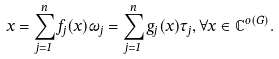<formula> <loc_0><loc_0><loc_500><loc_500>x = \sum _ { j = 1 } ^ { n } f _ { j } ( x ) \omega _ { j } = \sum _ { j = 1 } ^ { n } g _ { j } ( x ) \tau _ { j } , \forall x \in \mathbb { C } ^ { o ( G ) } .</formula> 